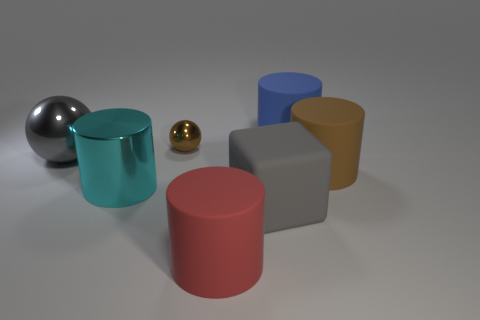There is a brown thing that is in front of the gray thing that is on the left side of the gray thing in front of the big brown thing; how big is it?
Ensure brevity in your answer.  Large. There is a gray thing that is made of the same material as the tiny brown thing; what is its size?
Ensure brevity in your answer.  Large. What is the size of the matte cylinder that is the same color as the small ball?
Provide a short and direct response. Large. There is a gray shiny ball; does it have the same size as the sphere right of the gray metallic ball?
Your answer should be very brief. No. What number of big things are the same color as the matte block?
Ensure brevity in your answer.  1. Are there any cylinders made of the same material as the tiny ball?
Offer a very short reply. Yes. What shape is the big red rubber thing?
Provide a succinct answer. Cylinder. There is a large gray object that is on the left side of the large matte thing that is left of the big gray cube; what shape is it?
Give a very brief answer. Sphere. How many other things are there of the same shape as the big cyan thing?
Ensure brevity in your answer.  3. There is a matte cylinder in front of the gray object on the right side of the brown shiny object; what size is it?
Keep it short and to the point. Large. 